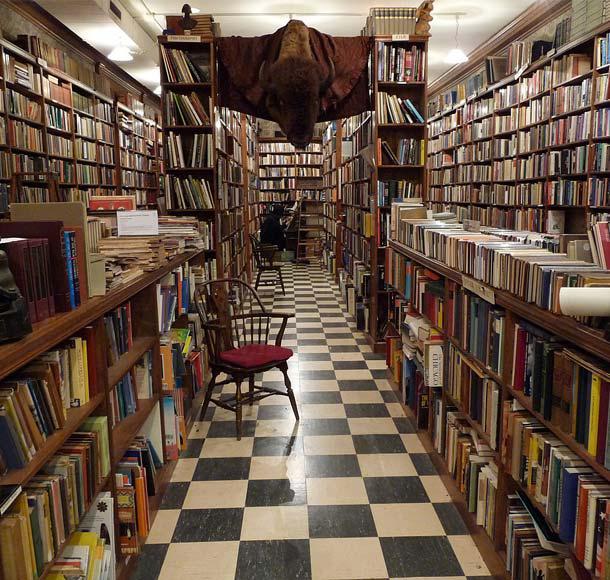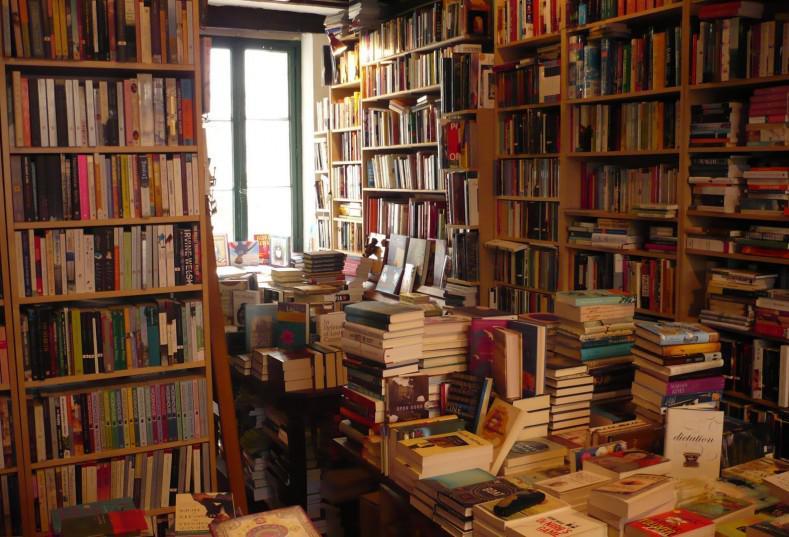The first image is the image on the left, the second image is the image on the right. For the images displayed, is the sentence "There are multiple people in a bookstore in the left image." factually correct? Answer yes or no. No. The first image is the image on the left, the second image is the image on the right. For the images displayed, is the sentence "There are at most 2 red chairs available for sitting." factually correct? Answer yes or no. Yes. 